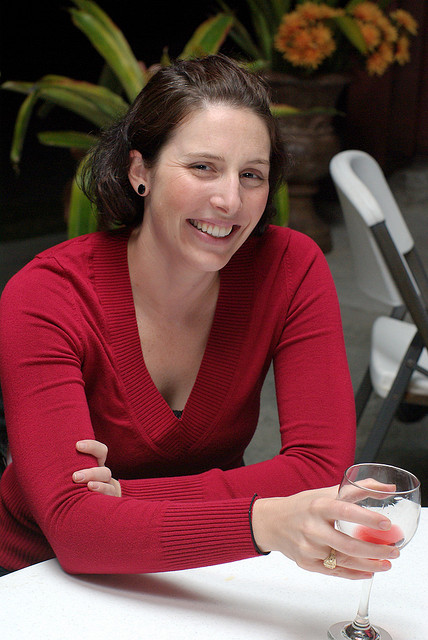<image>What state is on this woman's shirt? There is no state on this woman's shirt. What is a more polite synonym for the last word in the thought bubble? It is ambiguous as the last word in the thought bubble is not provided. What type of gem do the rings around each layer look like? I am not sure what type of gem the rings around each layer looks like. It could be diamond or ruby. Is this woman drunk yet? I don't know if the woman is drunk yet. What state is on this woman's shirt? I am not sure what state is on this woman's shirt. There seems to be no state on the shirt. What is a more polite synonym for the last word in the thought bubble? I am not sure. It can be seen 'nice', 'hello', 'smiling', 'smile', 'feces', 'none', 'good', or 'wine'. What type of gem do the rings around each layer look like? The type of gem the rings around each layer look like is ambiguous. It can be seen as ruby, diamond or none. Is this woman drunk yet? I don't know if this woman is drunk yet. It is not clear from the information provided. 